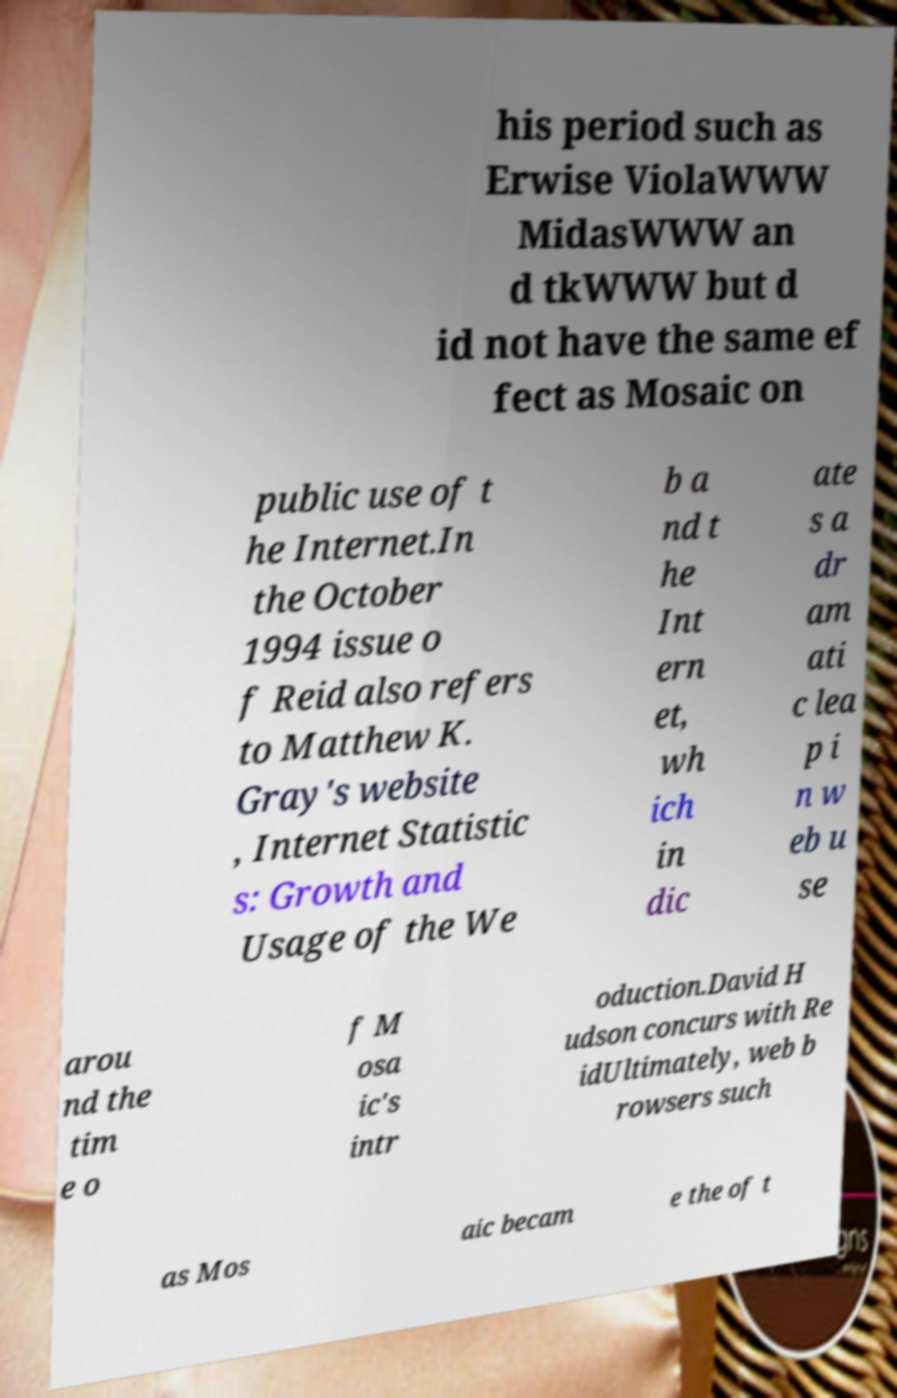Please read and relay the text visible in this image. What does it say? his period such as Erwise ViolaWWW MidasWWW an d tkWWW but d id not have the same ef fect as Mosaic on public use of t he Internet.In the October 1994 issue o f Reid also refers to Matthew K. Gray's website , Internet Statistic s: Growth and Usage of the We b a nd t he Int ern et, wh ich in dic ate s a dr am ati c lea p i n w eb u se arou nd the tim e o f M osa ic's intr oduction.David H udson concurs with Re idUltimately, web b rowsers such as Mos aic becam e the of t 